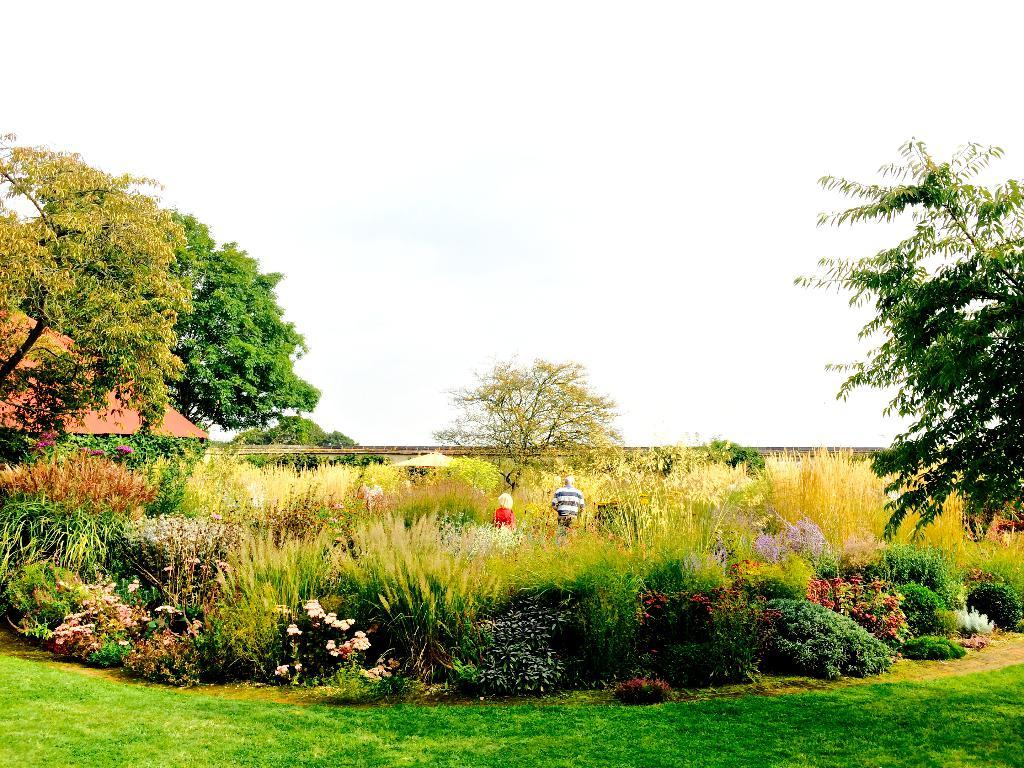How many people are present in the image? There are two people standing in the image. What type of vegetation can be seen in the image? There are plants and a group of trees in the image. What type of structure is visible in the image? There is a roof and a wall in the image. What is visible in the background of the image? The sky is visible in the image. What type of owl can be seen perched on the roof in the image? There is no owl present in the image; only people, plants, trees, a roof, and a wall are visible. 